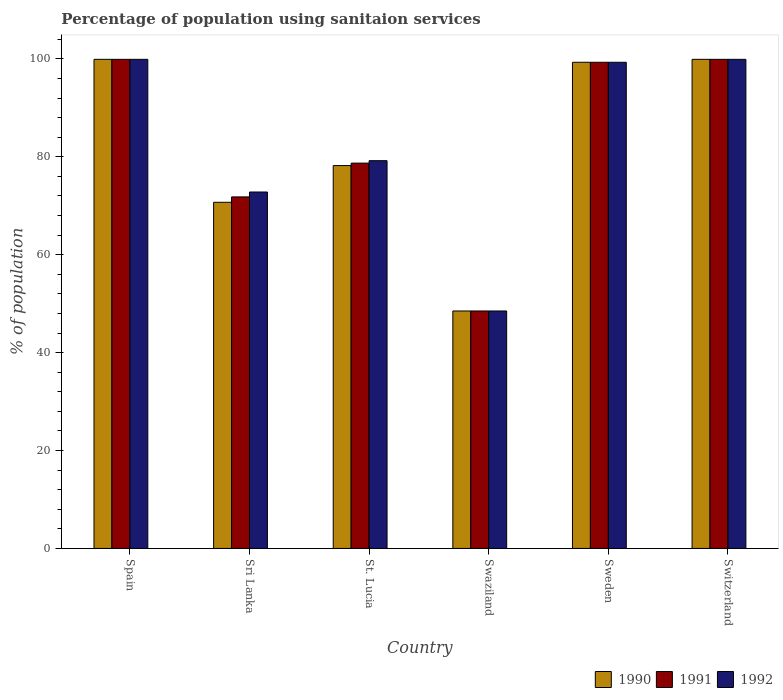How many groups of bars are there?
Your response must be concise. 6. How many bars are there on the 6th tick from the right?
Offer a terse response. 3. What is the label of the 6th group of bars from the left?
Keep it short and to the point. Switzerland. What is the percentage of population using sanitaion services in 1991 in Sweden?
Keep it short and to the point. 99.3. Across all countries, what is the maximum percentage of population using sanitaion services in 1990?
Offer a very short reply. 99.9. Across all countries, what is the minimum percentage of population using sanitaion services in 1992?
Provide a short and direct response. 48.5. In which country was the percentage of population using sanitaion services in 1990 minimum?
Provide a succinct answer. Swaziland. What is the total percentage of population using sanitaion services in 1991 in the graph?
Provide a succinct answer. 498.1. What is the difference between the percentage of population using sanitaion services in 1991 in Sri Lanka and the percentage of population using sanitaion services in 1990 in Spain?
Your response must be concise. -28.1. What is the average percentage of population using sanitaion services in 1992 per country?
Give a very brief answer. 83.27. What is the difference between the percentage of population using sanitaion services of/in 1990 and percentage of population using sanitaion services of/in 1992 in Swaziland?
Offer a very short reply. 0. In how many countries, is the percentage of population using sanitaion services in 1990 greater than 72 %?
Provide a short and direct response. 4. What is the ratio of the percentage of population using sanitaion services in 1990 in St. Lucia to that in Sweden?
Ensure brevity in your answer.  0.79. Is the percentage of population using sanitaion services in 1990 in Sri Lanka less than that in St. Lucia?
Your answer should be compact. Yes. Is the difference between the percentage of population using sanitaion services in 1990 in Sri Lanka and Swaziland greater than the difference between the percentage of population using sanitaion services in 1992 in Sri Lanka and Swaziland?
Offer a terse response. No. What is the difference between the highest and the second highest percentage of population using sanitaion services in 1990?
Ensure brevity in your answer.  -0.6. What is the difference between the highest and the lowest percentage of population using sanitaion services in 1991?
Your answer should be compact. 51.4. Is the sum of the percentage of population using sanitaion services in 1991 in Spain and Swaziland greater than the maximum percentage of population using sanitaion services in 1992 across all countries?
Provide a succinct answer. Yes. Are all the bars in the graph horizontal?
Provide a short and direct response. No. What is the difference between two consecutive major ticks on the Y-axis?
Your answer should be very brief. 20. Are the values on the major ticks of Y-axis written in scientific E-notation?
Your answer should be very brief. No. Does the graph contain any zero values?
Offer a terse response. No. Does the graph contain grids?
Your answer should be very brief. No. How many legend labels are there?
Provide a short and direct response. 3. How are the legend labels stacked?
Give a very brief answer. Horizontal. What is the title of the graph?
Ensure brevity in your answer.  Percentage of population using sanitaion services. Does "1995" appear as one of the legend labels in the graph?
Your answer should be compact. No. What is the label or title of the Y-axis?
Ensure brevity in your answer.  % of population. What is the % of population of 1990 in Spain?
Ensure brevity in your answer.  99.9. What is the % of population of 1991 in Spain?
Provide a short and direct response. 99.9. What is the % of population in 1992 in Spain?
Provide a short and direct response. 99.9. What is the % of population of 1990 in Sri Lanka?
Offer a very short reply. 70.7. What is the % of population in 1991 in Sri Lanka?
Keep it short and to the point. 71.8. What is the % of population of 1992 in Sri Lanka?
Offer a very short reply. 72.8. What is the % of population in 1990 in St. Lucia?
Keep it short and to the point. 78.2. What is the % of population in 1991 in St. Lucia?
Your response must be concise. 78.7. What is the % of population in 1992 in St. Lucia?
Your response must be concise. 79.2. What is the % of population of 1990 in Swaziland?
Provide a short and direct response. 48.5. What is the % of population in 1991 in Swaziland?
Offer a terse response. 48.5. What is the % of population in 1992 in Swaziland?
Offer a very short reply. 48.5. What is the % of population of 1990 in Sweden?
Provide a short and direct response. 99.3. What is the % of population in 1991 in Sweden?
Offer a terse response. 99.3. What is the % of population in 1992 in Sweden?
Your response must be concise. 99.3. What is the % of population of 1990 in Switzerland?
Provide a succinct answer. 99.9. What is the % of population in 1991 in Switzerland?
Your answer should be very brief. 99.9. What is the % of population of 1992 in Switzerland?
Your answer should be compact. 99.9. Across all countries, what is the maximum % of population of 1990?
Make the answer very short. 99.9. Across all countries, what is the maximum % of population of 1991?
Your answer should be compact. 99.9. Across all countries, what is the maximum % of population of 1992?
Offer a very short reply. 99.9. Across all countries, what is the minimum % of population in 1990?
Your answer should be very brief. 48.5. Across all countries, what is the minimum % of population of 1991?
Ensure brevity in your answer.  48.5. Across all countries, what is the minimum % of population of 1992?
Give a very brief answer. 48.5. What is the total % of population of 1990 in the graph?
Provide a short and direct response. 496.5. What is the total % of population of 1991 in the graph?
Offer a terse response. 498.1. What is the total % of population of 1992 in the graph?
Your answer should be compact. 499.6. What is the difference between the % of population in 1990 in Spain and that in Sri Lanka?
Give a very brief answer. 29.2. What is the difference between the % of population in 1991 in Spain and that in Sri Lanka?
Offer a terse response. 28.1. What is the difference between the % of population in 1992 in Spain and that in Sri Lanka?
Your answer should be very brief. 27.1. What is the difference between the % of population in 1990 in Spain and that in St. Lucia?
Your response must be concise. 21.7. What is the difference between the % of population of 1991 in Spain and that in St. Lucia?
Offer a terse response. 21.2. What is the difference between the % of population of 1992 in Spain and that in St. Lucia?
Make the answer very short. 20.7. What is the difference between the % of population in 1990 in Spain and that in Swaziland?
Ensure brevity in your answer.  51.4. What is the difference between the % of population in 1991 in Spain and that in Swaziland?
Provide a short and direct response. 51.4. What is the difference between the % of population in 1992 in Spain and that in Swaziland?
Provide a succinct answer. 51.4. What is the difference between the % of population of 1991 in Spain and that in Sweden?
Offer a terse response. 0.6. What is the difference between the % of population of 1992 in Spain and that in Switzerland?
Provide a short and direct response. 0. What is the difference between the % of population of 1990 in Sri Lanka and that in St. Lucia?
Offer a very short reply. -7.5. What is the difference between the % of population in 1992 in Sri Lanka and that in St. Lucia?
Offer a very short reply. -6.4. What is the difference between the % of population in 1990 in Sri Lanka and that in Swaziland?
Give a very brief answer. 22.2. What is the difference between the % of population of 1991 in Sri Lanka and that in Swaziland?
Your answer should be very brief. 23.3. What is the difference between the % of population of 1992 in Sri Lanka and that in Swaziland?
Offer a terse response. 24.3. What is the difference between the % of population in 1990 in Sri Lanka and that in Sweden?
Your response must be concise. -28.6. What is the difference between the % of population of 1991 in Sri Lanka and that in Sweden?
Make the answer very short. -27.5. What is the difference between the % of population in 1992 in Sri Lanka and that in Sweden?
Your answer should be very brief. -26.5. What is the difference between the % of population in 1990 in Sri Lanka and that in Switzerland?
Your answer should be compact. -29.2. What is the difference between the % of population of 1991 in Sri Lanka and that in Switzerland?
Make the answer very short. -28.1. What is the difference between the % of population in 1992 in Sri Lanka and that in Switzerland?
Your response must be concise. -27.1. What is the difference between the % of population in 1990 in St. Lucia and that in Swaziland?
Offer a very short reply. 29.7. What is the difference between the % of population in 1991 in St. Lucia and that in Swaziland?
Make the answer very short. 30.2. What is the difference between the % of population in 1992 in St. Lucia and that in Swaziland?
Your answer should be compact. 30.7. What is the difference between the % of population of 1990 in St. Lucia and that in Sweden?
Your response must be concise. -21.1. What is the difference between the % of population of 1991 in St. Lucia and that in Sweden?
Your answer should be very brief. -20.6. What is the difference between the % of population of 1992 in St. Lucia and that in Sweden?
Give a very brief answer. -20.1. What is the difference between the % of population in 1990 in St. Lucia and that in Switzerland?
Give a very brief answer. -21.7. What is the difference between the % of population of 1991 in St. Lucia and that in Switzerland?
Offer a very short reply. -21.2. What is the difference between the % of population of 1992 in St. Lucia and that in Switzerland?
Provide a succinct answer. -20.7. What is the difference between the % of population in 1990 in Swaziland and that in Sweden?
Your answer should be compact. -50.8. What is the difference between the % of population of 1991 in Swaziland and that in Sweden?
Your answer should be very brief. -50.8. What is the difference between the % of population in 1992 in Swaziland and that in Sweden?
Give a very brief answer. -50.8. What is the difference between the % of population of 1990 in Swaziland and that in Switzerland?
Offer a very short reply. -51.4. What is the difference between the % of population of 1991 in Swaziland and that in Switzerland?
Ensure brevity in your answer.  -51.4. What is the difference between the % of population of 1992 in Swaziland and that in Switzerland?
Offer a very short reply. -51.4. What is the difference between the % of population of 1990 in Sweden and that in Switzerland?
Your answer should be compact. -0.6. What is the difference between the % of population in 1991 in Sweden and that in Switzerland?
Offer a terse response. -0.6. What is the difference between the % of population in 1992 in Sweden and that in Switzerland?
Your response must be concise. -0.6. What is the difference between the % of population of 1990 in Spain and the % of population of 1991 in Sri Lanka?
Keep it short and to the point. 28.1. What is the difference between the % of population of 1990 in Spain and the % of population of 1992 in Sri Lanka?
Your response must be concise. 27.1. What is the difference between the % of population of 1991 in Spain and the % of population of 1992 in Sri Lanka?
Give a very brief answer. 27.1. What is the difference between the % of population of 1990 in Spain and the % of population of 1991 in St. Lucia?
Ensure brevity in your answer.  21.2. What is the difference between the % of population in 1990 in Spain and the % of population in 1992 in St. Lucia?
Keep it short and to the point. 20.7. What is the difference between the % of population in 1991 in Spain and the % of population in 1992 in St. Lucia?
Give a very brief answer. 20.7. What is the difference between the % of population of 1990 in Spain and the % of population of 1991 in Swaziland?
Your answer should be very brief. 51.4. What is the difference between the % of population of 1990 in Spain and the % of population of 1992 in Swaziland?
Offer a terse response. 51.4. What is the difference between the % of population of 1991 in Spain and the % of population of 1992 in Swaziland?
Provide a short and direct response. 51.4. What is the difference between the % of population of 1990 in Spain and the % of population of 1991 in Sweden?
Provide a succinct answer. 0.6. What is the difference between the % of population of 1990 in Spain and the % of population of 1992 in Switzerland?
Your answer should be very brief. 0. What is the difference between the % of population of 1990 in Sri Lanka and the % of population of 1991 in St. Lucia?
Provide a succinct answer. -8. What is the difference between the % of population in 1990 in Sri Lanka and the % of population in 1992 in Swaziland?
Provide a succinct answer. 22.2. What is the difference between the % of population in 1991 in Sri Lanka and the % of population in 1992 in Swaziland?
Provide a succinct answer. 23.3. What is the difference between the % of population of 1990 in Sri Lanka and the % of population of 1991 in Sweden?
Provide a succinct answer. -28.6. What is the difference between the % of population of 1990 in Sri Lanka and the % of population of 1992 in Sweden?
Your response must be concise. -28.6. What is the difference between the % of population of 1991 in Sri Lanka and the % of population of 1992 in Sweden?
Make the answer very short. -27.5. What is the difference between the % of population in 1990 in Sri Lanka and the % of population in 1991 in Switzerland?
Your response must be concise. -29.2. What is the difference between the % of population in 1990 in Sri Lanka and the % of population in 1992 in Switzerland?
Your answer should be very brief. -29.2. What is the difference between the % of population of 1991 in Sri Lanka and the % of population of 1992 in Switzerland?
Provide a short and direct response. -28.1. What is the difference between the % of population of 1990 in St. Lucia and the % of population of 1991 in Swaziland?
Offer a terse response. 29.7. What is the difference between the % of population of 1990 in St. Lucia and the % of population of 1992 in Swaziland?
Your answer should be very brief. 29.7. What is the difference between the % of population of 1991 in St. Lucia and the % of population of 1992 in Swaziland?
Your answer should be very brief. 30.2. What is the difference between the % of population in 1990 in St. Lucia and the % of population in 1991 in Sweden?
Keep it short and to the point. -21.1. What is the difference between the % of population in 1990 in St. Lucia and the % of population in 1992 in Sweden?
Ensure brevity in your answer.  -21.1. What is the difference between the % of population in 1991 in St. Lucia and the % of population in 1992 in Sweden?
Your response must be concise. -20.6. What is the difference between the % of population in 1990 in St. Lucia and the % of population in 1991 in Switzerland?
Make the answer very short. -21.7. What is the difference between the % of population in 1990 in St. Lucia and the % of population in 1992 in Switzerland?
Your answer should be very brief. -21.7. What is the difference between the % of population of 1991 in St. Lucia and the % of population of 1992 in Switzerland?
Keep it short and to the point. -21.2. What is the difference between the % of population of 1990 in Swaziland and the % of population of 1991 in Sweden?
Ensure brevity in your answer.  -50.8. What is the difference between the % of population of 1990 in Swaziland and the % of population of 1992 in Sweden?
Offer a terse response. -50.8. What is the difference between the % of population in 1991 in Swaziland and the % of population in 1992 in Sweden?
Your response must be concise. -50.8. What is the difference between the % of population of 1990 in Swaziland and the % of population of 1991 in Switzerland?
Make the answer very short. -51.4. What is the difference between the % of population of 1990 in Swaziland and the % of population of 1992 in Switzerland?
Keep it short and to the point. -51.4. What is the difference between the % of population of 1991 in Swaziland and the % of population of 1992 in Switzerland?
Your answer should be very brief. -51.4. What is the difference between the % of population in 1990 in Sweden and the % of population in 1991 in Switzerland?
Offer a terse response. -0.6. What is the difference between the % of population in 1991 in Sweden and the % of population in 1992 in Switzerland?
Offer a very short reply. -0.6. What is the average % of population in 1990 per country?
Provide a succinct answer. 82.75. What is the average % of population of 1991 per country?
Your answer should be compact. 83.02. What is the average % of population of 1992 per country?
Provide a succinct answer. 83.27. What is the difference between the % of population of 1990 and % of population of 1992 in Spain?
Your response must be concise. 0. What is the difference between the % of population in 1990 and % of population in 1992 in St. Lucia?
Your answer should be very brief. -1. What is the difference between the % of population of 1990 and % of population of 1991 in Swaziland?
Your answer should be compact. 0. What is the difference between the % of population in 1990 and % of population in 1992 in Swaziland?
Offer a terse response. 0. What is the difference between the % of population of 1990 and % of population of 1991 in Sweden?
Ensure brevity in your answer.  0. What is the difference between the % of population of 1990 and % of population of 1992 in Sweden?
Give a very brief answer. 0. What is the difference between the % of population in 1991 and % of population in 1992 in Sweden?
Offer a terse response. 0. What is the ratio of the % of population of 1990 in Spain to that in Sri Lanka?
Keep it short and to the point. 1.41. What is the ratio of the % of population of 1991 in Spain to that in Sri Lanka?
Your answer should be compact. 1.39. What is the ratio of the % of population of 1992 in Spain to that in Sri Lanka?
Make the answer very short. 1.37. What is the ratio of the % of population in 1990 in Spain to that in St. Lucia?
Make the answer very short. 1.28. What is the ratio of the % of population of 1991 in Spain to that in St. Lucia?
Ensure brevity in your answer.  1.27. What is the ratio of the % of population of 1992 in Spain to that in St. Lucia?
Provide a succinct answer. 1.26. What is the ratio of the % of population of 1990 in Spain to that in Swaziland?
Keep it short and to the point. 2.06. What is the ratio of the % of population of 1991 in Spain to that in Swaziland?
Provide a succinct answer. 2.06. What is the ratio of the % of population in 1992 in Spain to that in Swaziland?
Give a very brief answer. 2.06. What is the ratio of the % of population of 1990 in Spain to that in Sweden?
Provide a short and direct response. 1.01. What is the ratio of the % of population in 1992 in Spain to that in Sweden?
Keep it short and to the point. 1.01. What is the ratio of the % of population in 1990 in Spain to that in Switzerland?
Offer a terse response. 1. What is the ratio of the % of population of 1990 in Sri Lanka to that in St. Lucia?
Provide a succinct answer. 0.9. What is the ratio of the % of population in 1991 in Sri Lanka to that in St. Lucia?
Give a very brief answer. 0.91. What is the ratio of the % of population of 1992 in Sri Lanka to that in St. Lucia?
Offer a very short reply. 0.92. What is the ratio of the % of population in 1990 in Sri Lanka to that in Swaziland?
Give a very brief answer. 1.46. What is the ratio of the % of population in 1991 in Sri Lanka to that in Swaziland?
Keep it short and to the point. 1.48. What is the ratio of the % of population of 1992 in Sri Lanka to that in Swaziland?
Make the answer very short. 1.5. What is the ratio of the % of population in 1990 in Sri Lanka to that in Sweden?
Give a very brief answer. 0.71. What is the ratio of the % of population in 1991 in Sri Lanka to that in Sweden?
Your answer should be very brief. 0.72. What is the ratio of the % of population of 1992 in Sri Lanka to that in Sweden?
Offer a very short reply. 0.73. What is the ratio of the % of population in 1990 in Sri Lanka to that in Switzerland?
Your response must be concise. 0.71. What is the ratio of the % of population of 1991 in Sri Lanka to that in Switzerland?
Offer a terse response. 0.72. What is the ratio of the % of population of 1992 in Sri Lanka to that in Switzerland?
Offer a very short reply. 0.73. What is the ratio of the % of population of 1990 in St. Lucia to that in Swaziland?
Make the answer very short. 1.61. What is the ratio of the % of population in 1991 in St. Lucia to that in Swaziland?
Offer a very short reply. 1.62. What is the ratio of the % of population in 1992 in St. Lucia to that in Swaziland?
Your answer should be compact. 1.63. What is the ratio of the % of population in 1990 in St. Lucia to that in Sweden?
Offer a very short reply. 0.79. What is the ratio of the % of population of 1991 in St. Lucia to that in Sweden?
Your answer should be very brief. 0.79. What is the ratio of the % of population in 1992 in St. Lucia to that in Sweden?
Ensure brevity in your answer.  0.8. What is the ratio of the % of population in 1990 in St. Lucia to that in Switzerland?
Give a very brief answer. 0.78. What is the ratio of the % of population in 1991 in St. Lucia to that in Switzerland?
Offer a very short reply. 0.79. What is the ratio of the % of population of 1992 in St. Lucia to that in Switzerland?
Offer a terse response. 0.79. What is the ratio of the % of population in 1990 in Swaziland to that in Sweden?
Ensure brevity in your answer.  0.49. What is the ratio of the % of population in 1991 in Swaziland to that in Sweden?
Provide a short and direct response. 0.49. What is the ratio of the % of population in 1992 in Swaziland to that in Sweden?
Offer a terse response. 0.49. What is the ratio of the % of population in 1990 in Swaziland to that in Switzerland?
Your response must be concise. 0.49. What is the ratio of the % of population of 1991 in Swaziland to that in Switzerland?
Make the answer very short. 0.49. What is the ratio of the % of population in 1992 in Swaziland to that in Switzerland?
Offer a very short reply. 0.49. What is the ratio of the % of population in 1990 in Sweden to that in Switzerland?
Provide a succinct answer. 0.99. What is the ratio of the % of population of 1992 in Sweden to that in Switzerland?
Provide a succinct answer. 0.99. What is the difference between the highest and the second highest % of population in 1991?
Offer a terse response. 0. What is the difference between the highest and the second highest % of population in 1992?
Ensure brevity in your answer.  0. What is the difference between the highest and the lowest % of population in 1990?
Make the answer very short. 51.4. What is the difference between the highest and the lowest % of population of 1991?
Your answer should be very brief. 51.4. What is the difference between the highest and the lowest % of population of 1992?
Provide a succinct answer. 51.4. 